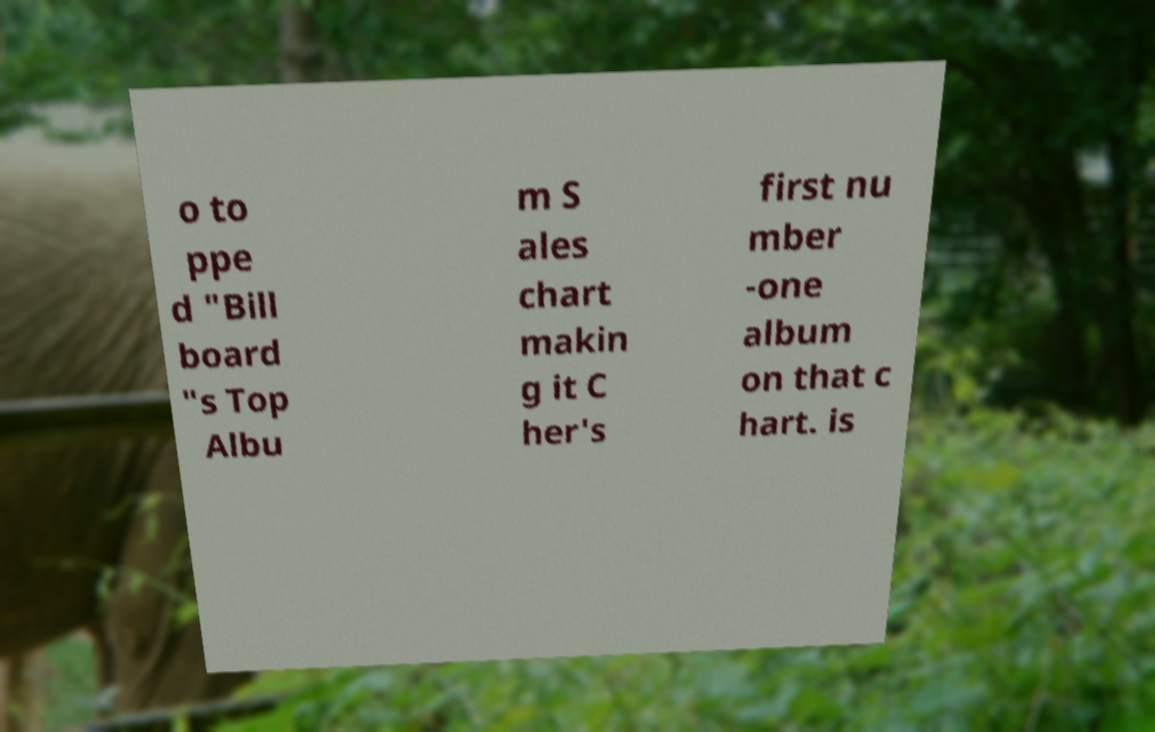Could you assist in decoding the text presented in this image and type it out clearly? o to ppe d "Bill board "s Top Albu m S ales chart makin g it C her's first nu mber -one album on that c hart. is 